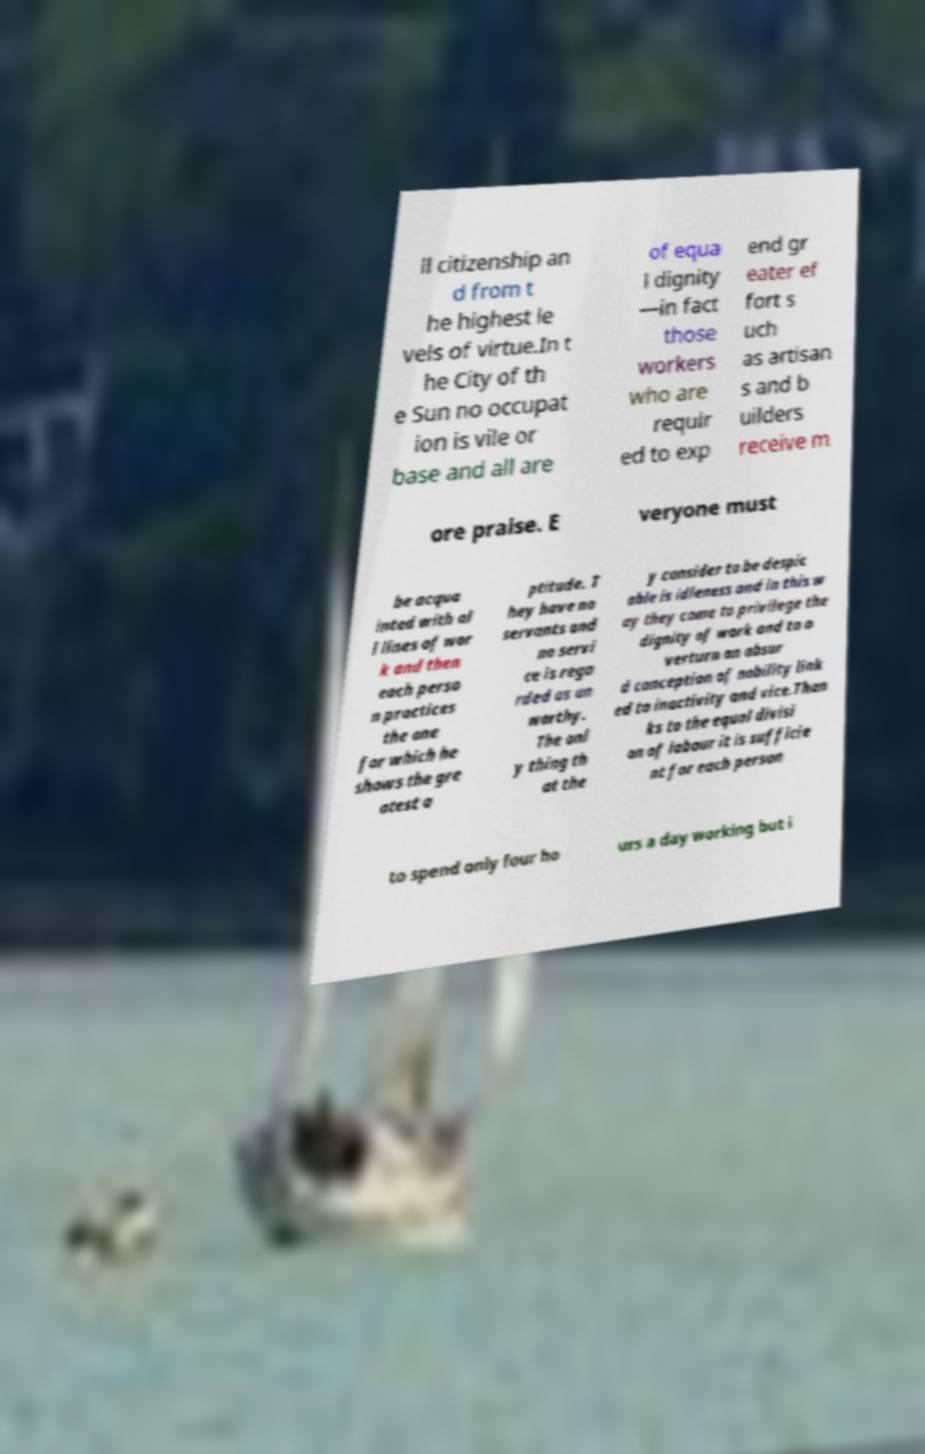Could you assist in decoding the text presented in this image and type it out clearly? ll citizenship an d from t he highest le vels of virtue.In t he City of th e Sun no occupat ion is vile or base and all are of equa l dignity —in fact those workers who are requir ed to exp end gr eater ef fort s uch as artisan s and b uilders receive m ore praise. E veryone must be acqua inted with al l lines of wor k and then each perso n practices the one for which he shows the gre atest a ptitude. T hey have no servants and no servi ce is rega rded as un worthy. The onl y thing th at the y consider to be despic able is idleness and in this w ay they come to privilege the dignity of work and to o verturn an absur d conception of nobility link ed to inactivity and vice.Than ks to the equal divisi on of labour it is sufficie nt for each person to spend only four ho urs a day working but i 